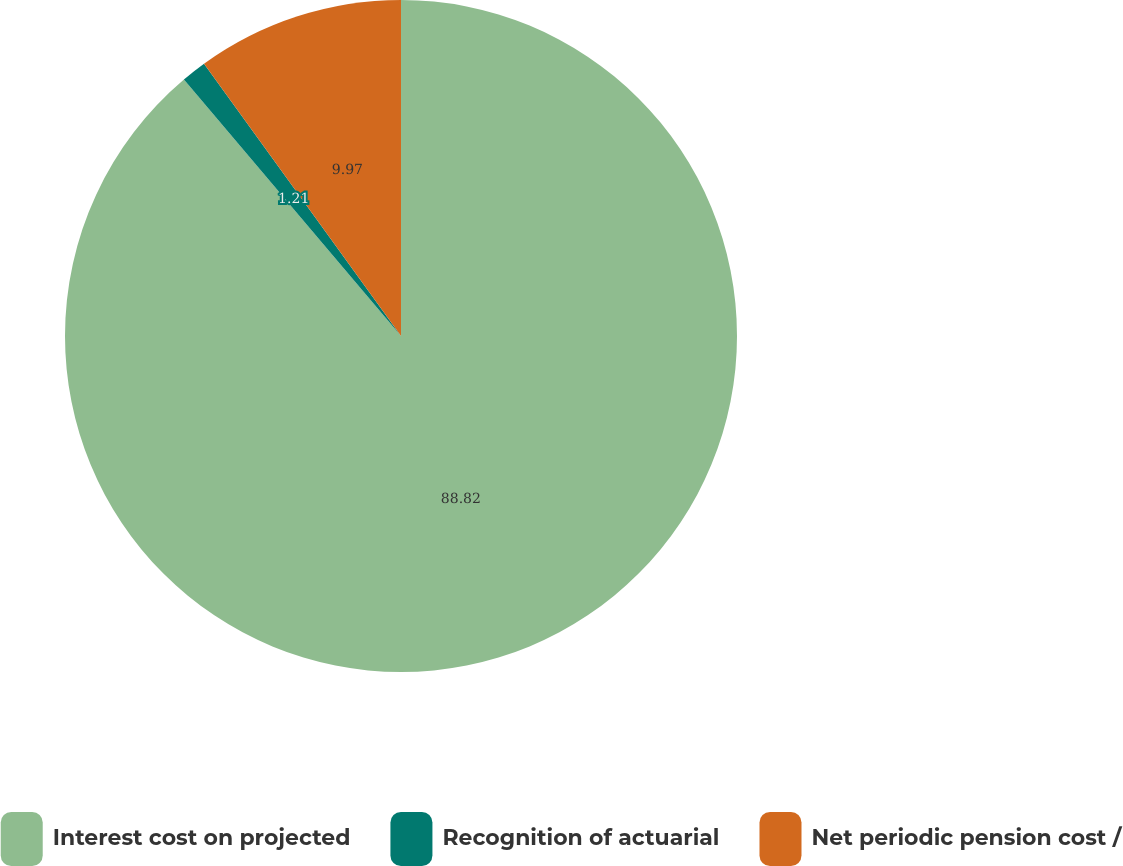Convert chart. <chart><loc_0><loc_0><loc_500><loc_500><pie_chart><fcel>Interest cost on projected<fcel>Recognition of actuarial<fcel>Net periodic pension cost /<nl><fcel>88.82%<fcel>1.21%<fcel>9.97%<nl></chart> 